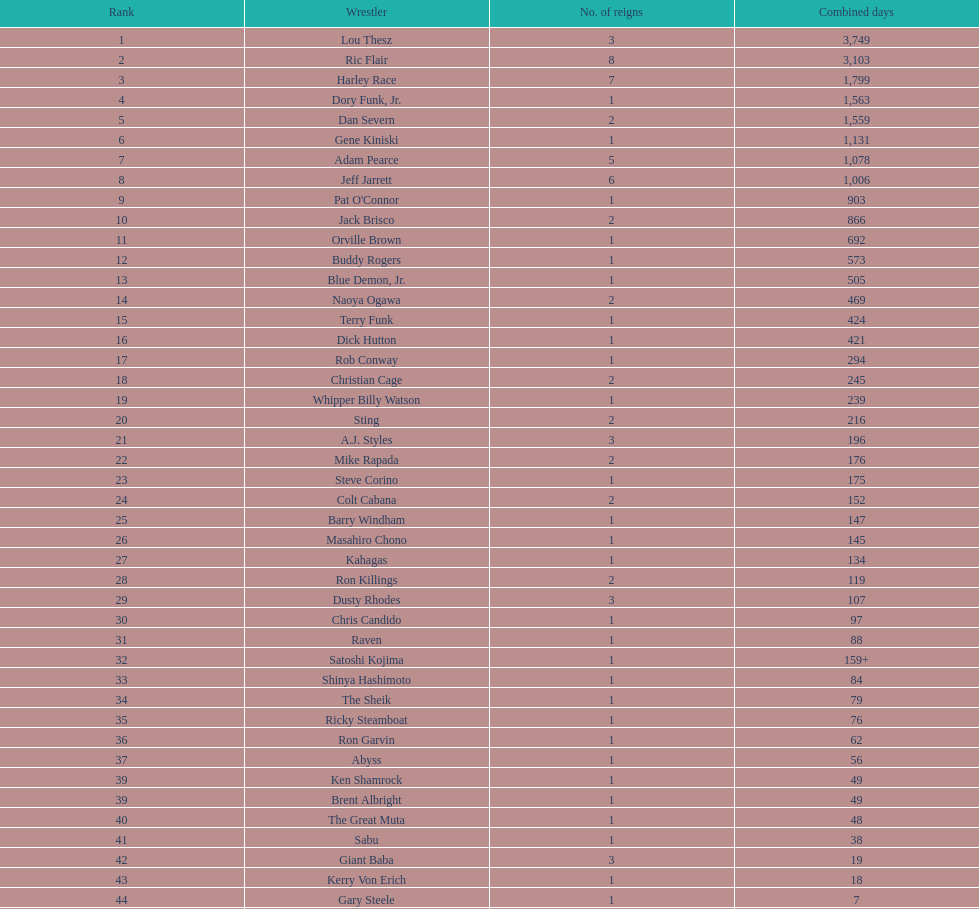Between gene kiniski and ric flair, who held the nwa world heavyweight championship for a longer duration? Ric Flair. 